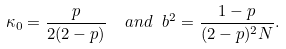Convert formula to latex. <formula><loc_0><loc_0><loc_500><loc_500>\kappa _ { 0 } = \frac { p } { 2 ( 2 - p ) } \ \ a n d \ b ^ { 2 } = \frac { 1 - p } { ( 2 - p ) ^ { 2 } N } .</formula> 